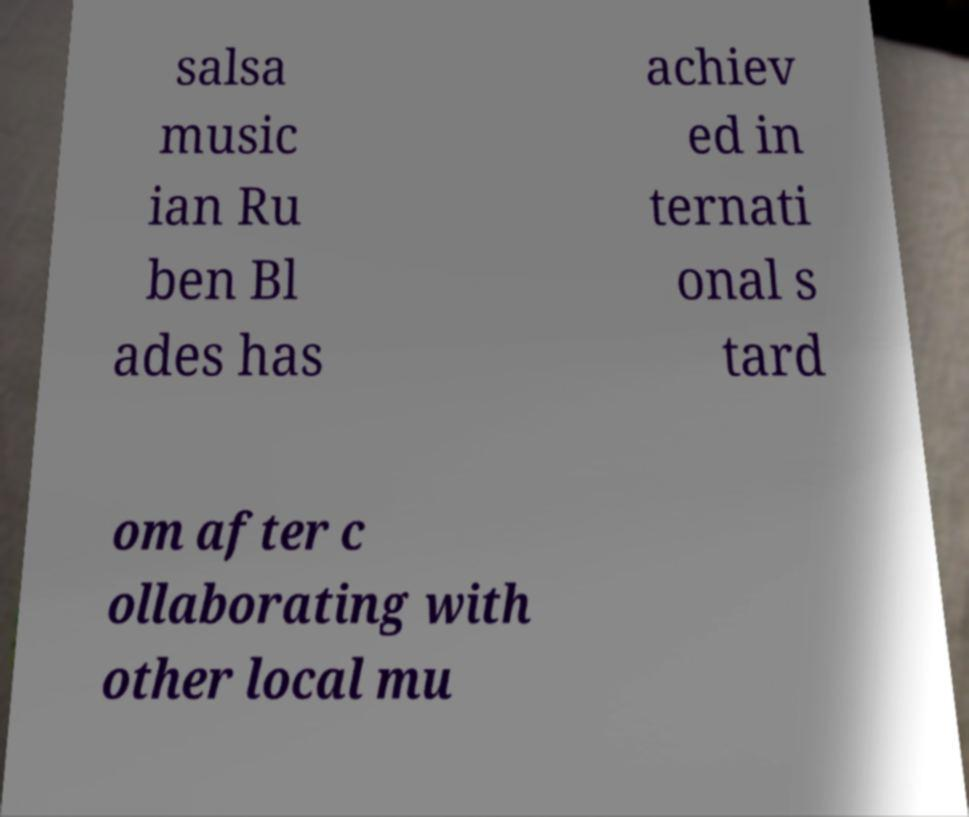Could you extract and type out the text from this image? salsa music ian Ru ben Bl ades has achiev ed in ternati onal s tard om after c ollaborating with other local mu 